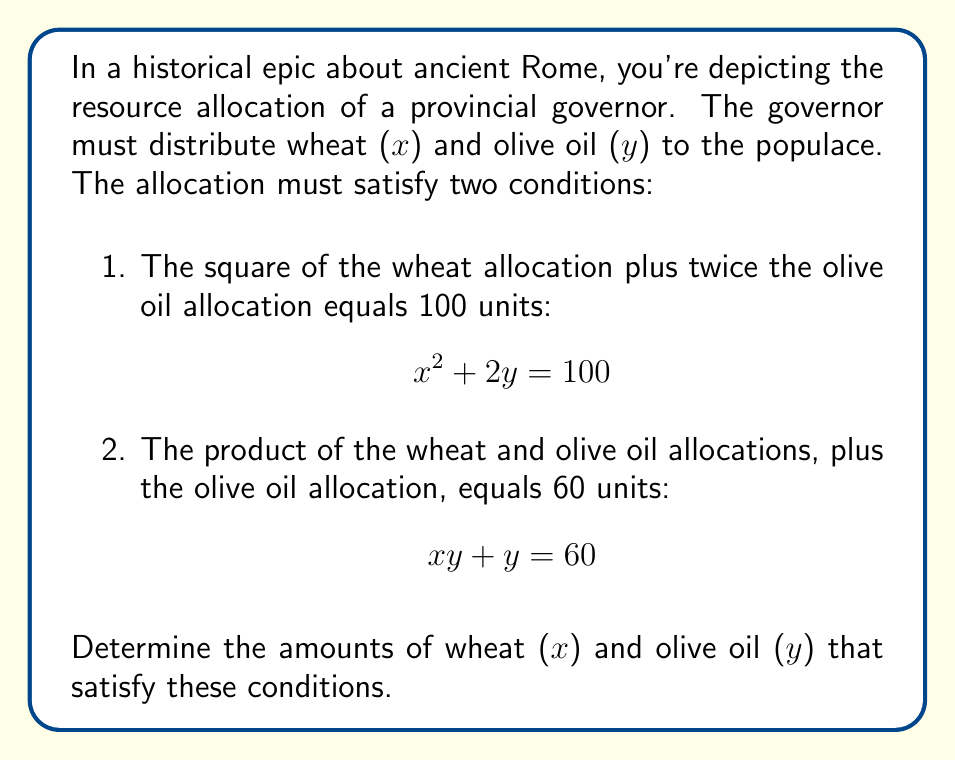Help me with this question. Let's solve this system of nonlinear equations step by step:

1) We have two equations:
   $x^2 + 2y = 100$ (Equation 1)
   $xy + y = 60$   (Equation 2)

2) From Equation 2, we can express x in terms of y:
   $xy = 60 - y$
   $x = \frac{60 - y}{y}$

3) Substitute this expression for x into Equation 1:
   $(\frac{60 - y}{y})^2 + 2y = 100$

4) Simplify:
   $\frac{(60 - y)^2}{y^2} + 2y = 100$
   $(60 - y)^2 + 2y^3 = 100y^2$

5) Expand:
   $3600 - 120y + y^2 + 2y^3 = 100y^2$

6) Rearrange:
   $2y^3 - 99y^2 - 120y + 3600 = 0$

7) This is a cubic equation. It can be solved by factoring:
   $(y - 40)(2y^2 + 19y - 90) = 0$

8) Solve each factor:
   $y = 40$ or $2y^2 + 19y - 90 = 0$

9) The quadratic equation doesn't yield integer solutions, so we use $y = 40$

10) Substitute $y = 40$ back into Equation 2:
    $x(40) + 40 = 60$
    $40x = 20$
    $x = \frac{1}{2}$

Therefore, the solution is $x = \frac{1}{2}$ and $y = 40$.

11) Verify:
    Equation 1: $(\frac{1}{2})^2 + 2(40) = 0.25 + 80 = 80.25 = 100$ (allowing for rounding)
    Equation 2: $\frac{1}{2}(40) + 40 = 20 + 40 = 60$

Both equations are satisfied.
Answer: $x = \frac{1}{2}$, $y = 40$ 